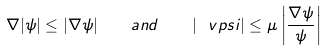Convert formula to latex. <formula><loc_0><loc_0><loc_500><loc_500>\nabla | \psi | \leq | \nabla \psi | \quad a n d \quad | \ v p s i | \leq \mu \left | \frac { \nabla \psi } { \psi } \right |</formula> 